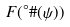<formula> <loc_0><loc_0><loc_500><loc_500>F ( ^ { \circ } \# ( \psi ) )</formula> 